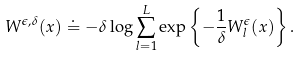Convert formula to latex. <formula><loc_0><loc_0><loc_500><loc_500>W ^ { \epsilon , \delta } ( x ) \doteq - \delta \log \sum _ { l = 1 } ^ { L } \exp \left \{ - \frac { 1 } { \delta } W ^ { \epsilon } _ { l } ( x ) \right \} .</formula> 